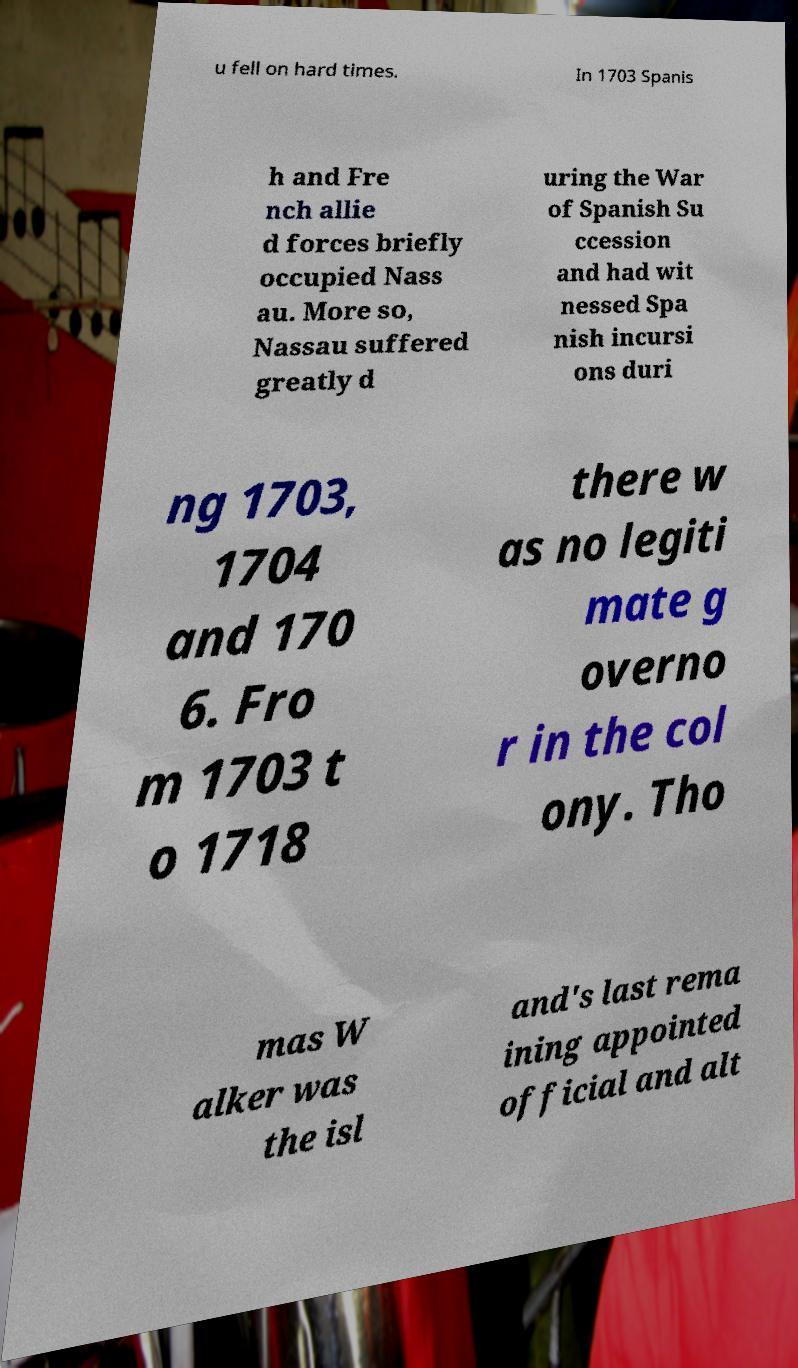Please identify and transcribe the text found in this image. u fell on hard times. In 1703 Spanis h and Fre nch allie d forces briefly occupied Nass au. More so, Nassau suffered greatly d uring the War of Spanish Su ccession and had wit nessed Spa nish incursi ons duri ng 1703, 1704 and 170 6. Fro m 1703 t o 1718 there w as no legiti mate g overno r in the col ony. Tho mas W alker was the isl and's last rema ining appointed official and alt 